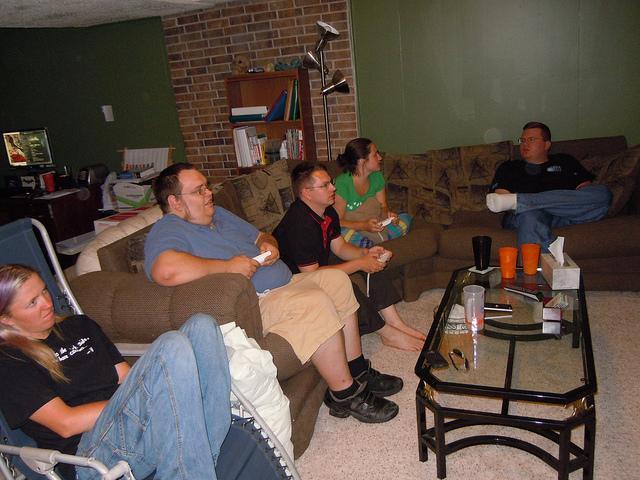How many orange cups are there?
Give a very brief answer. 2. How many people are wearing glasses?
Give a very brief answer. 3. How many people are sitting?
Give a very brief answer. 5. How many males?
Give a very brief answer. 3. How many chairs are in the photo?
Give a very brief answer. 2. How many people are in the photo?
Give a very brief answer. 5. 